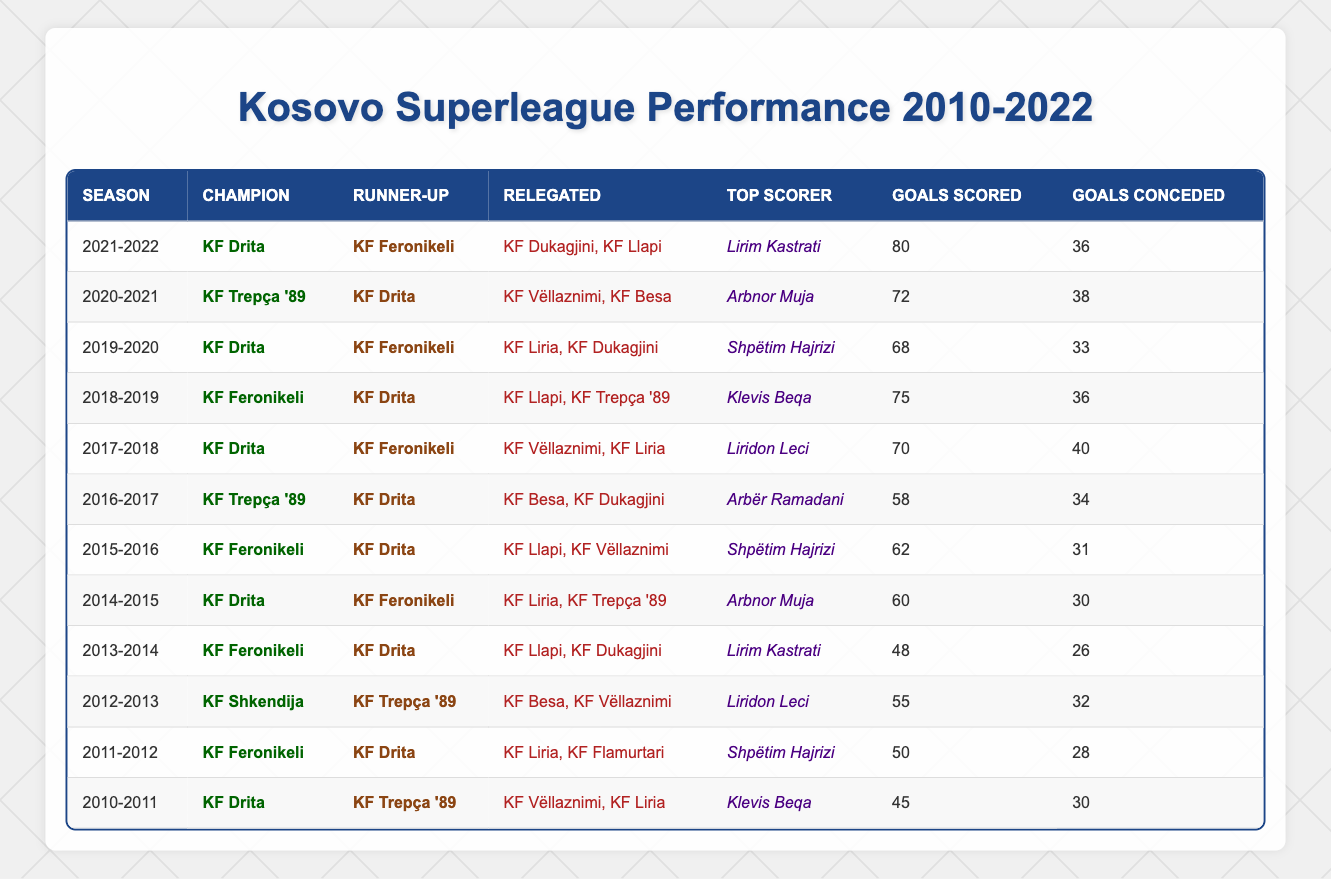What team won the championship in the 2015-2016 season? The table shows that the champion for the 2015-2016 season is listed as KF Feronikeli.
Answer: KF Feronikeli How many goals did KF Drita score in the 2019-2020 season? According to the table, KF Drita scored 68 goals in the 2019-2020 season.
Answer: 68 Which team was relegated in the 2012-2013 season? The table indicates that KF Besa and KF Vëllaznimi were relegated during the 2012-2013 season.
Answer: KF Besa, KF Vëllaznimi Who was the top scorer in the 2014-2015 season? The table specifies that Arbnor Muja was the top scorer for the 2014-2015 season.
Answer: Arbnor Muja What is the total number of goals scored by champions from 2010 to 2022? Summing the champion goals: (45 + 50 + 55 + 48 + 60 + 62 + 58 + 70 + 75 + 68 + 72 + 80) =  682.
Answer: 682 Did any team win the championship consecutively from 2010 to 2022? By examining the table, KF Drita won the championship in 2010-2011, 2014-2015, 2017-2018, 2019-2020, and 2021-2022, indicating they did not win consecutive championships but were successful multiple times.
Answer: No Which team consistently placed either first or second from 2010-2012? Reviewing the table shows that KF Drita placed first in 2010-2011 and second in 2011-2012, while KF Feronikeli placed second in 2010-2011 and first in 2011-2012, demonstrating both teams' consistent high placement.
Answer: KF Drita and KF Feronikeli Was there a season where both the champion and runner-up scored more than 70 goals? Looking at the table, the 2018-2019 season shows KF Feronikeli as champion with 75 goals and KF Drita as runner-up with 70 goals, confirming that both scored over 70 goals.
Answer: Yes Which season had the highest goals scored by a top scorer and how many goals did they score? The top scorer in the 2021-2022 season was Lirim Kastrati, who scored 80 goals, which is the highest recorded in the table.
Answer: 80 goals in 2021-2022 How many total goals were conceded by KF Drita throughout all the seasons listed? By adding KF Drita's goals conceded in the scoring instances: (30 + 28 + 34 + 40 + 36) = 168 for the seasons they were noted, totalling to 168.
Answer: 168 What is the difference between the highest and lowest goals scored by champions? The highest goals scored by a champion was 80 (KF Drita, 2021-2022) and the lowest was 45 (KF Drita, 2010-2011), resulting in a difference of 35 goals.
Answer: 35 